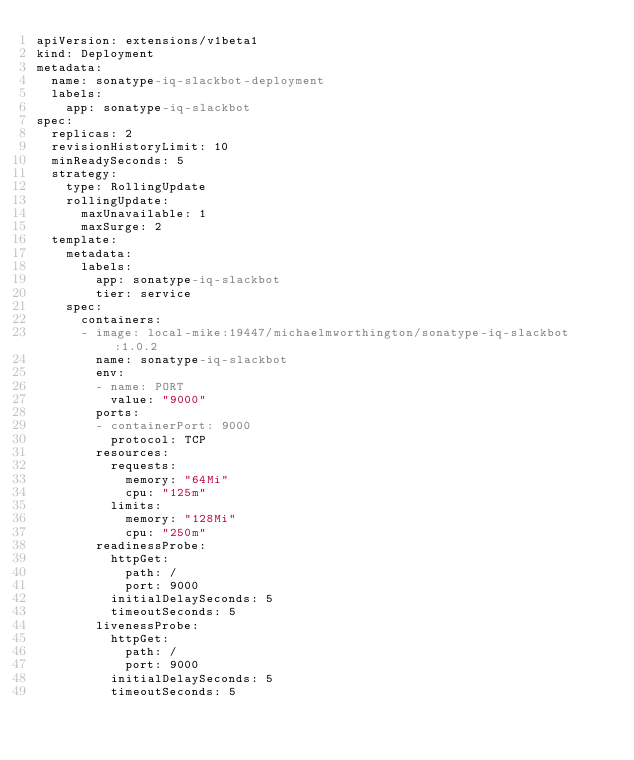Convert code to text. <code><loc_0><loc_0><loc_500><loc_500><_YAML_>apiVersion: extensions/v1beta1
kind: Deployment
metadata:
  name: sonatype-iq-slackbot-deployment
  labels:
    app: sonatype-iq-slackbot
spec:
  replicas: 2
  revisionHistoryLimit: 10
  minReadySeconds: 5
  strategy:
    type: RollingUpdate
    rollingUpdate:
      maxUnavailable: 1
      maxSurge: 2
  template:
    metadata:
      labels:
        app: sonatype-iq-slackbot
        tier: service
    spec:
      containers:
      - image: local-mike:19447/michaelmworthington/sonatype-iq-slackbot:1.0.2
        name: sonatype-iq-slackbot
        env:
        - name: PORT
          value: "9000"
        ports:
        - containerPort: 9000
          protocol: TCP
        resources:
          requests:
            memory: "64Mi"
            cpu: "125m"
          limits:
            memory: "128Mi"
            cpu: "250m"
        readinessProbe:
          httpGet:
            path: /
            port: 9000
          initialDelaySeconds: 5
          timeoutSeconds: 5
        livenessProbe:
          httpGet:
            path: /
            port: 9000
          initialDelaySeconds: 5
          timeoutSeconds: 5       
</code> 